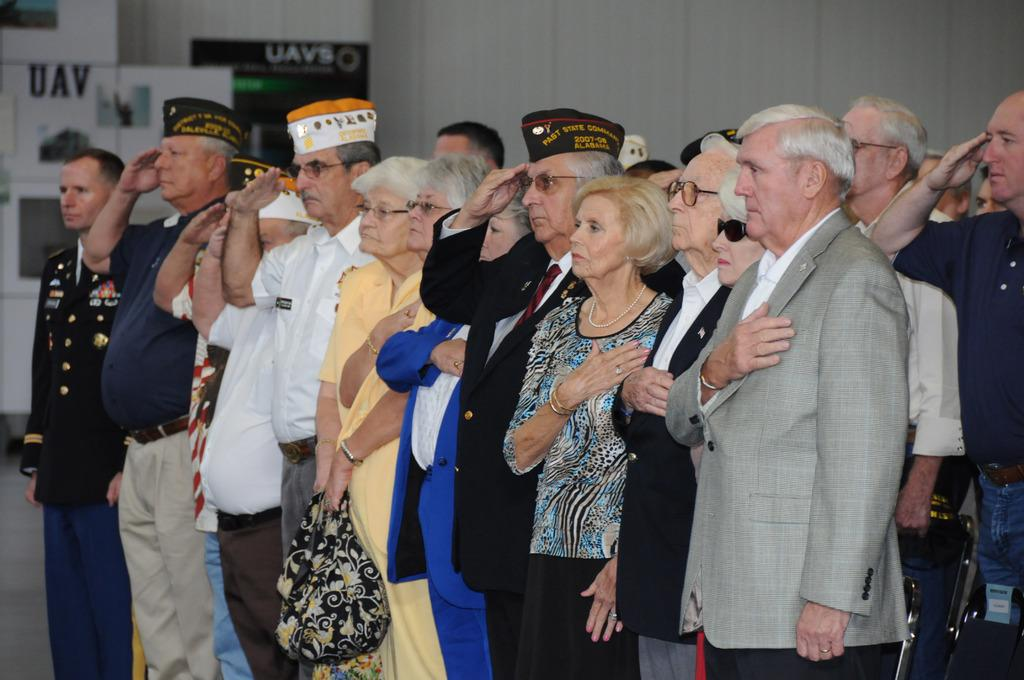What is happening in the image? There is a group of people standing in the image. What can be seen in the background of the image? There are boards with text and a wall visible in the background of the image. What type of lawyer is reading the text on the boards in the image? There is no lawyer or reading activity present in the image. 